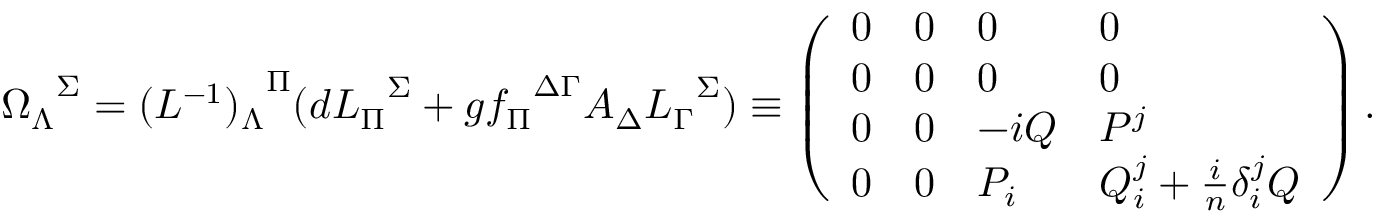Convert formula to latex. <formula><loc_0><loc_0><loc_500><loc_500>{ \Omega _ { \Lambda } } ^ { \Sigma } = { ( L ^ { - 1 } ) _ { \Lambda } } ^ { \Pi } ( d { L _ { \Pi } } ^ { \Sigma } + g { f _ { \Pi } } ^ { \Delta \Gamma } A _ { \Delta } { L _ { \Gamma } } ^ { \Sigma } ) \equiv \left ( \begin{array} { l l l l } { 0 } & { 0 } & { 0 } & { 0 } \\ { 0 } & { 0 } & { 0 } & { 0 } \\ { 0 } & { 0 } & { - i Q } & { { P ^ { j } } } \\ { 0 } & { 0 } & { { P _ { i } } } & { { Q _ { i } ^ { j } + { \frac { i } { n } } \delta _ { i } ^ { j } Q } } \end{array} \right ) .</formula> 